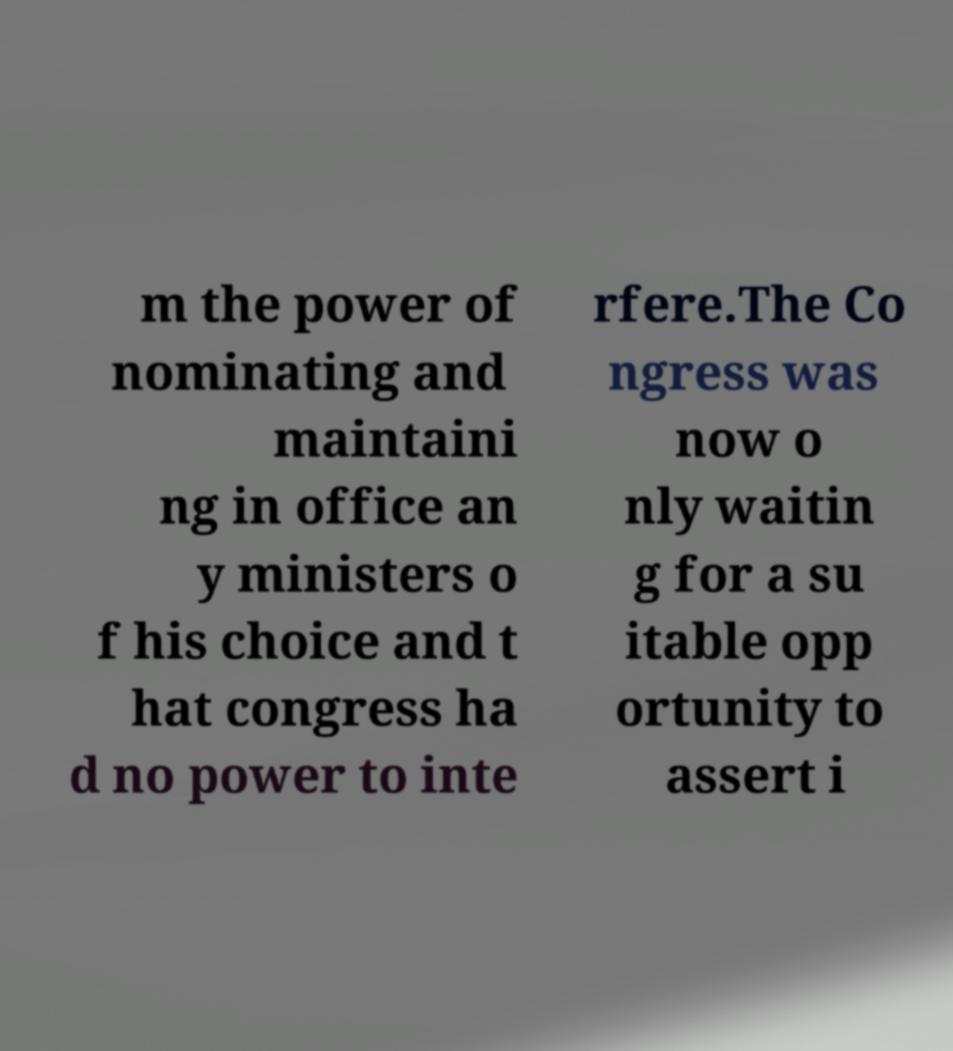For documentation purposes, I need the text within this image transcribed. Could you provide that? m the power of nominating and maintaini ng in office an y ministers o f his choice and t hat congress ha d no power to inte rfere.The Co ngress was now o nly waitin g for a su itable opp ortunity to assert i 